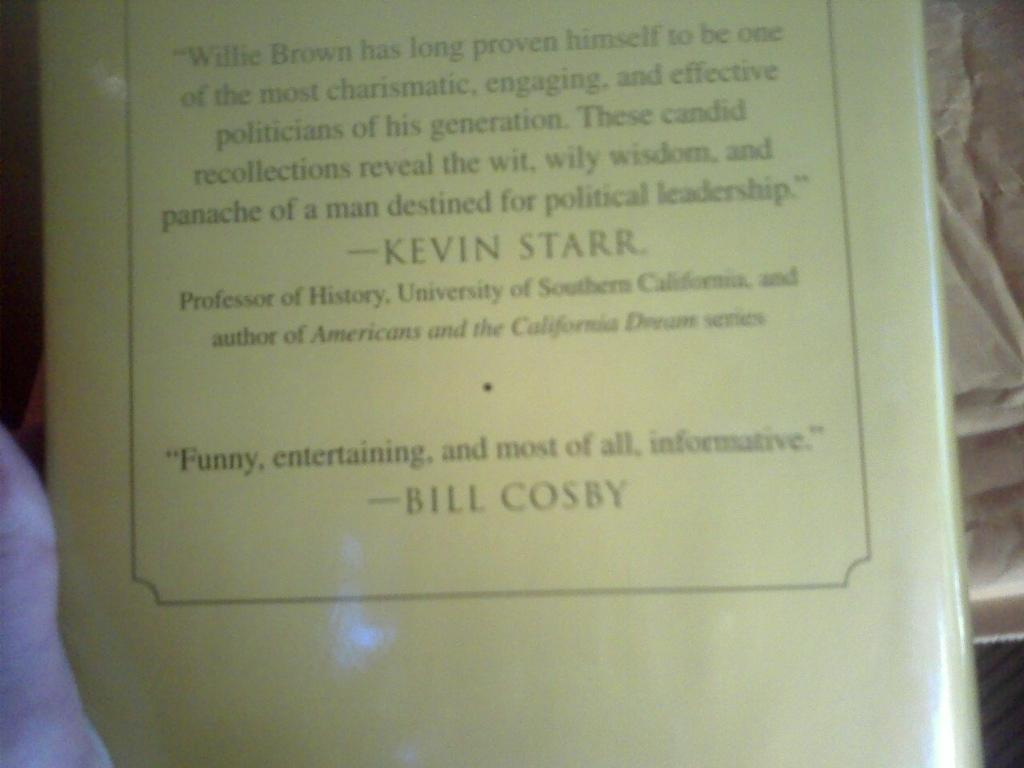<image>
Create a compact narrative representing the image presented. A books back cover gives a quote by Kevin Starr and Bill Cosby 